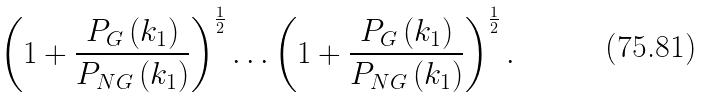<formula> <loc_0><loc_0><loc_500><loc_500>\left ( 1 + \frac { P _ { G } \left ( k _ { 1 } \right ) } { P _ { N G } \left ( k _ { 1 } \right ) } \right ) ^ { \frac { 1 } { 2 } } \dots \left ( 1 + \frac { P _ { G } \left ( k _ { 1 } \right ) } { P _ { N G } \left ( k _ { 1 } \right ) } \right ) ^ { \frac { 1 } { 2 } } .</formula> 